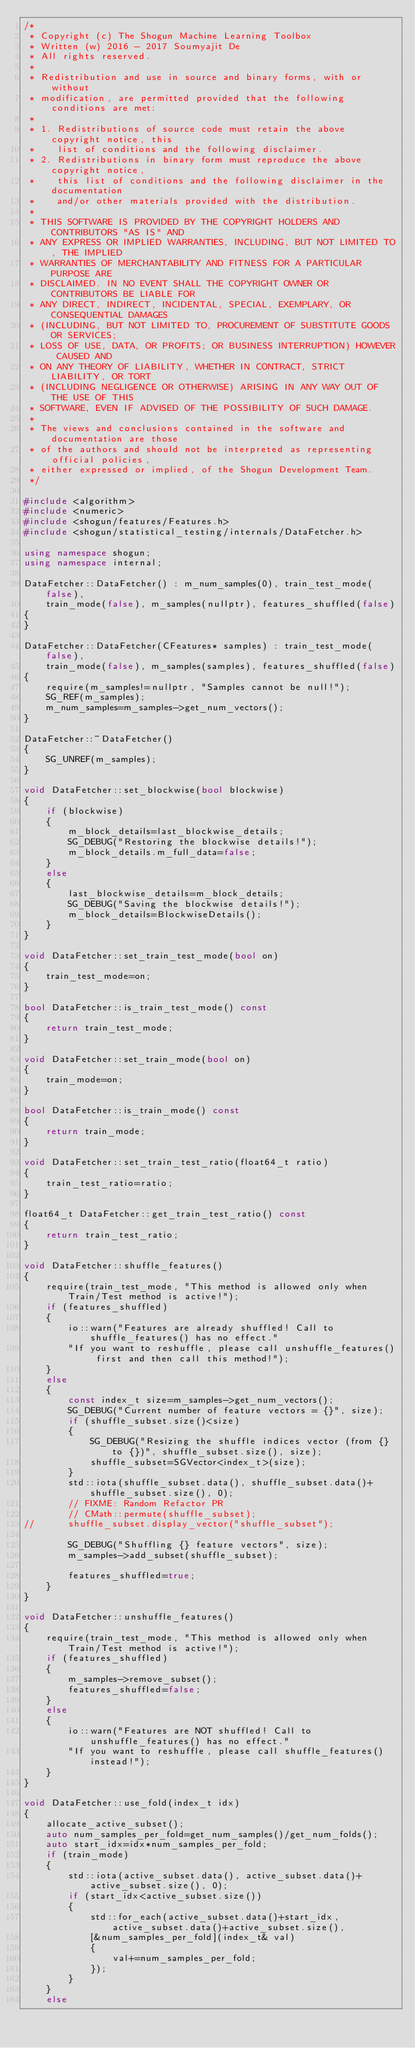Convert code to text. <code><loc_0><loc_0><loc_500><loc_500><_C++_>/*
 * Copyright (c) The Shogun Machine Learning Toolbox
 * Written (w) 2016 - 2017 Soumyajit De
 * All rights reserved.
 *
 * Redistribution and use in source and binary forms, with or without
 * modification, are permitted provided that the following conditions are met:
 *
 * 1. Redistributions of source code must retain the above copyright notice, this
 *    list of conditions and the following disclaimer.
 * 2. Redistributions in binary form must reproduce the above copyright notice,
 *    this list of conditions and the following disclaimer in the documentation
 *    and/or other materials provided with the distribution.
 *
 * THIS SOFTWARE IS PROVIDED BY THE COPYRIGHT HOLDERS AND CONTRIBUTORS "AS IS" AND
 * ANY EXPRESS OR IMPLIED WARRANTIES, INCLUDING, BUT NOT LIMITED TO, THE IMPLIED
 * WARRANTIES OF MERCHANTABILITY AND FITNESS FOR A PARTICULAR PURPOSE ARE
 * DISCLAIMED. IN NO EVENT SHALL THE COPYRIGHT OWNER OR CONTRIBUTORS BE LIABLE FOR
 * ANY DIRECT, INDIRECT, INCIDENTAL, SPECIAL, EXEMPLARY, OR CONSEQUENTIAL DAMAGES
 * (INCLUDING, BUT NOT LIMITED TO, PROCUREMENT OF SUBSTITUTE GOODS OR SERVICES;
 * LOSS OF USE, DATA, OR PROFITS; OR BUSINESS INTERRUPTION) HOWEVER CAUSED AND
 * ON ANY THEORY OF LIABILITY, WHETHER IN CONTRACT, STRICT LIABILITY, OR TORT
 * (INCLUDING NEGLIGENCE OR OTHERWISE) ARISING IN ANY WAY OUT OF THE USE OF THIS
 * SOFTWARE, EVEN IF ADVISED OF THE POSSIBILITY OF SUCH DAMAGE.
 *
 * The views and conclusions contained in the software and documentation are those
 * of the authors and should not be interpreted as representing official policies,
 * either expressed or implied, of the Shogun Development Team.
 */

#include <algorithm>
#include <numeric>
#include <shogun/features/Features.h>
#include <shogun/statistical_testing/internals/DataFetcher.h>

using namespace shogun;
using namespace internal;

DataFetcher::DataFetcher() : m_num_samples(0), train_test_mode(false),
	train_mode(false), m_samples(nullptr), features_shuffled(false)
{
}

DataFetcher::DataFetcher(CFeatures* samples) : train_test_mode(false),
   	train_mode(false), m_samples(samples), features_shuffled(false)
{
	require(m_samples!=nullptr, "Samples cannot be null!");
	SG_REF(m_samples);
	m_num_samples=m_samples->get_num_vectors();
}

DataFetcher::~DataFetcher()
{
	SG_UNREF(m_samples);
}

void DataFetcher::set_blockwise(bool blockwise)
{
	if (blockwise)
	{
		m_block_details=last_blockwise_details;
		SG_DEBUG("Restoring the blockwise details!");
		m_block_details.m_full_data=false;
	}
	else
	{
		last_blockwise_details=m_block_details;
		SG_DEBUG("Saving the blockwise details!");
		m_block_details=BlockwiseDetails();
	}
}

void DataFetcher::set_train_test_mode(bool on)
{
	train_test_mode=on;
}

bool DataFetcher::is_train_test_mode() const
{
	return train_test_mode;
}

void DataFetcher::set_train_mode(bool on)
{
	train_mode=on;
}

bool DataFetcher::is_train_mode() const
{
	return train_mode;
}

void DataFetcher::set_train_test_ratio(float64_t ratio)
{
	train_test_ratio=ratio;
}

float64_t DataFetcher::get_train_test_ratio() const
{
	return train_test_ratio;
}

void DataFetcher::shuffle_features()
{
	require(train_test_mode, "This method is allowed only when Train/Test method is active!");
	if (features_shuffled)
	{
		io::warn("Features are already shuffled! Call to shuffle_features() has no effect."
		"If you want to reshuffle, please call unshuffle_features() first and then call this method!");
	}
	else
	{
		const index_t size=m_samples->get_num_vectors();
		SG_DEBUG("Current number of feature vectors = {}", size);
		if (shuffle_subset.size()<size)
		{
			SG_DEBUG("Resizing the shuffle indices vector (from {} to {})", shuffle_subset.size(), size);
			shuffle_subset=SGVector<index_t>(size);
		}
		std::iota(shuffle_subset.data(), shuffle_subset.data()+shuffle_subset.size(), 0);
		// FIXME: Random Refactor PR
		// CMath::permute(shuffle_subset);
//		shuffle_subset.display_vector("shuffle_subset");

		SG_DEBUG("Shuffling {} feature vectors", size);
		m_samples->add_subset(shuffle_subset);

		features_shuffled=true;
	}
}

void DataFetcher::unshuffle_features()
{
	require(train_test_mode, "This method is allowed only when Train/Test method is active!");
	if (features_shuffled)
	{
		m_samples->remove_subset();
		features_shuffled=false;
	}
	else
	{
		io::warn("Features are NOT shuffled! Call to unshuffle_features() has no effect."
		"If you want to reshuffle, please call shuffle_features() instead!");
	}
}

void DataFetcher::use_fold(index_t idx)
{
	allocate_active_subset();
	auto num_samples_per_fold=get_num_samples()/get_num_folds();
	auto start_idx=idx*num_samples_per_fold;
	if (train_mode)
	{
		std::iota(active_subset.data(), active_subset.data()+active_subset.size(), 0);
		if (start_idx<active_subset.size())
		{
			std::for_each(active_subset.data()+start_idx, active_subset.data()+active_subset.size(),
			[&num_samples_per_fold](index_t& val)
			{
				val+=num_samples_per_fold;
			});
		}
	}
	else</code> 